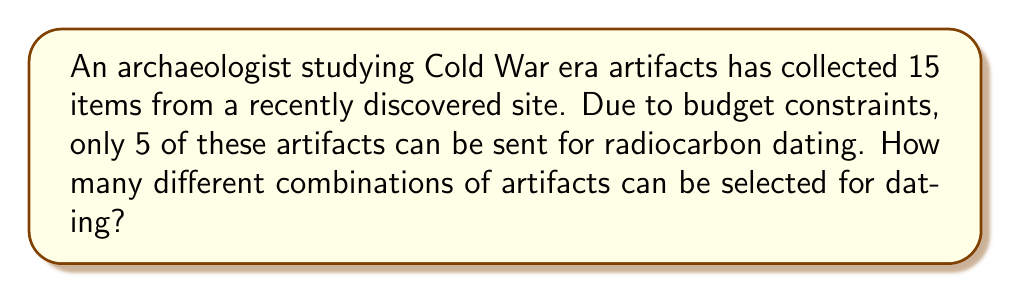Give your solution to this math problem. To solve this problem, we need to use the combination formula. We are selecting 5 items out of 15, where the order of selection doesn't matter (since we're just interested in which items are selected, not the order they're tested in).

The formula for combinations is:

$$C(n,r) = \frac{n!}{r!(n-r)!}$$

Where:
$n$ is the total number of items (15 in this case)
$r$ is the number of items being chosen (5 in this case)

Substituting our values:

$$C(15,5) = \frac{15!}{5!(15-5)!} = \frac{15!}{5!10!}$$

Expanding this:

$$\frac{15 \cdot 14 \cdot 13 \cdot 12 \cdot 11 \cdot 10!}{(5 \cdot 4 \cdot 3 \cdot 2 \cdot 1) \cdot 10!}$$

The 10! cancels out in the numerator and denominator:

$$\frac{15 \cdot 14 \cdot 13 \cdot 12 \cdot 11}{5 \cdot 4 \cdot 3 \cdot 2 \cdot 1}$$

Multiplying the numerator and denominator:

$$\frac{360360}{120} = 3003$$

Therefore, there are 3003 different possible combinations of artifacts that can be selected for radiocarbon dating.
Answer: 3003 combinations 